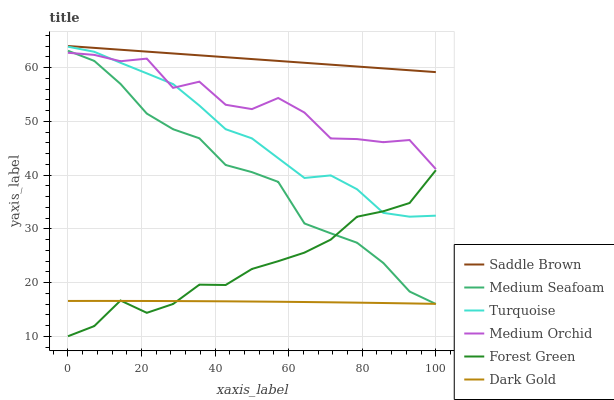Does Dark Gold have the minimum area under the curve?
Answer yes or no. Yes. Does Saddle Brown have the maximum area under the curve?
Answer yes or no. Yes. Does Medium Orchid have the minimum area under the curve?
Answer yes or no. No. Does Medium Orchid have the maximum area under the curve?
Answer yes or no. No. Is Saddle Brown the smoothest?
Answer yes or no. Yes. Is Medium Orchid the roughest?
Answer yes or no. Yes. Is Dark Gold the smoothest?
Answer yes or no. No. Is Dark Gold the roughest?
Answer yes or no. No. Does Forest Green have the lowest value?
Answer yes or no. Yes. Does Dark Gold have the lowest value?
Answer yes or no. No. Does Saddle Brown have the highest value?
Answer yes or no. Yes. Does Medium Orchid have the highest value?
Answer yes or no. No. Is Medium Seafoam less than Saddle Brown?
Answer yes or no. Yes. Is Saddle Brown greater than Medium Orchid?
Answer yes or no. Yes. Does Forest Green intersect Turquoise?
Answer yes or no. Yes. Is Forest Green less than Turquoise?
Answer yes or no. No. Is Forest Green greater than Turquoise?
Answer yes or no. No. Does Medium Seafoam intersect Saddle Brown?
Answer yes or no. No. 